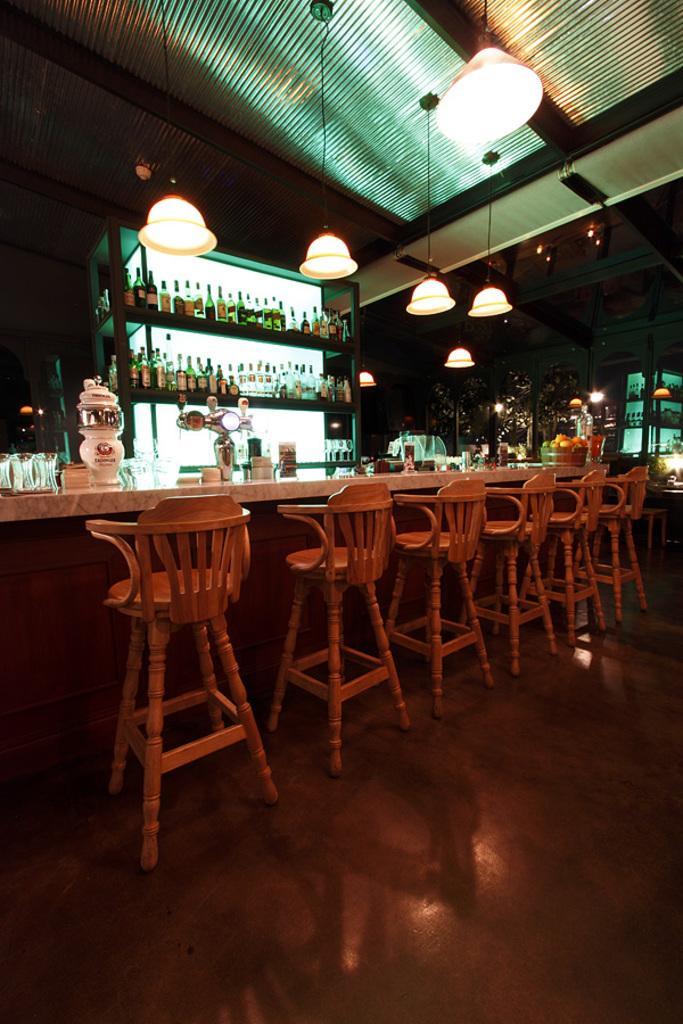How would you summarize this image in a sentence or two? This image is clicked inside bar, there are chairs in the front of table with glasses,bowls,jars on it, in the back there is rack with many wine bottles on it, there are lights over the ceiling. 